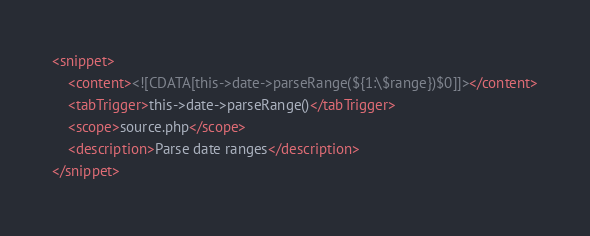<code> <loc_0><loc_0><loc_500><loc_500><_XML_><snippet>
    <content><![CDATA[this->date->parseRange(${1:\$range})$0]]></content>
    <tabTrigger>this->date->parseRange()</tabTrigger>
    <scope>source.php</scope>
    <description>Parse date ranges</description>
</snippet></code> 